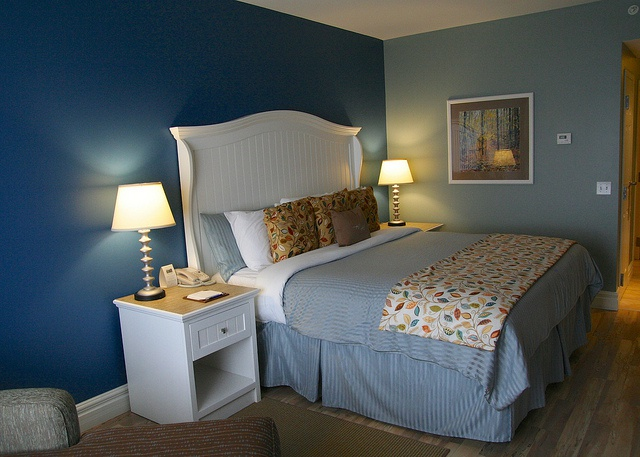Describe the objects in this image and their specific colors. I can see bed in navy, gray, darkgray, and black tones and chair in navy, gray, and black tones in this image. 